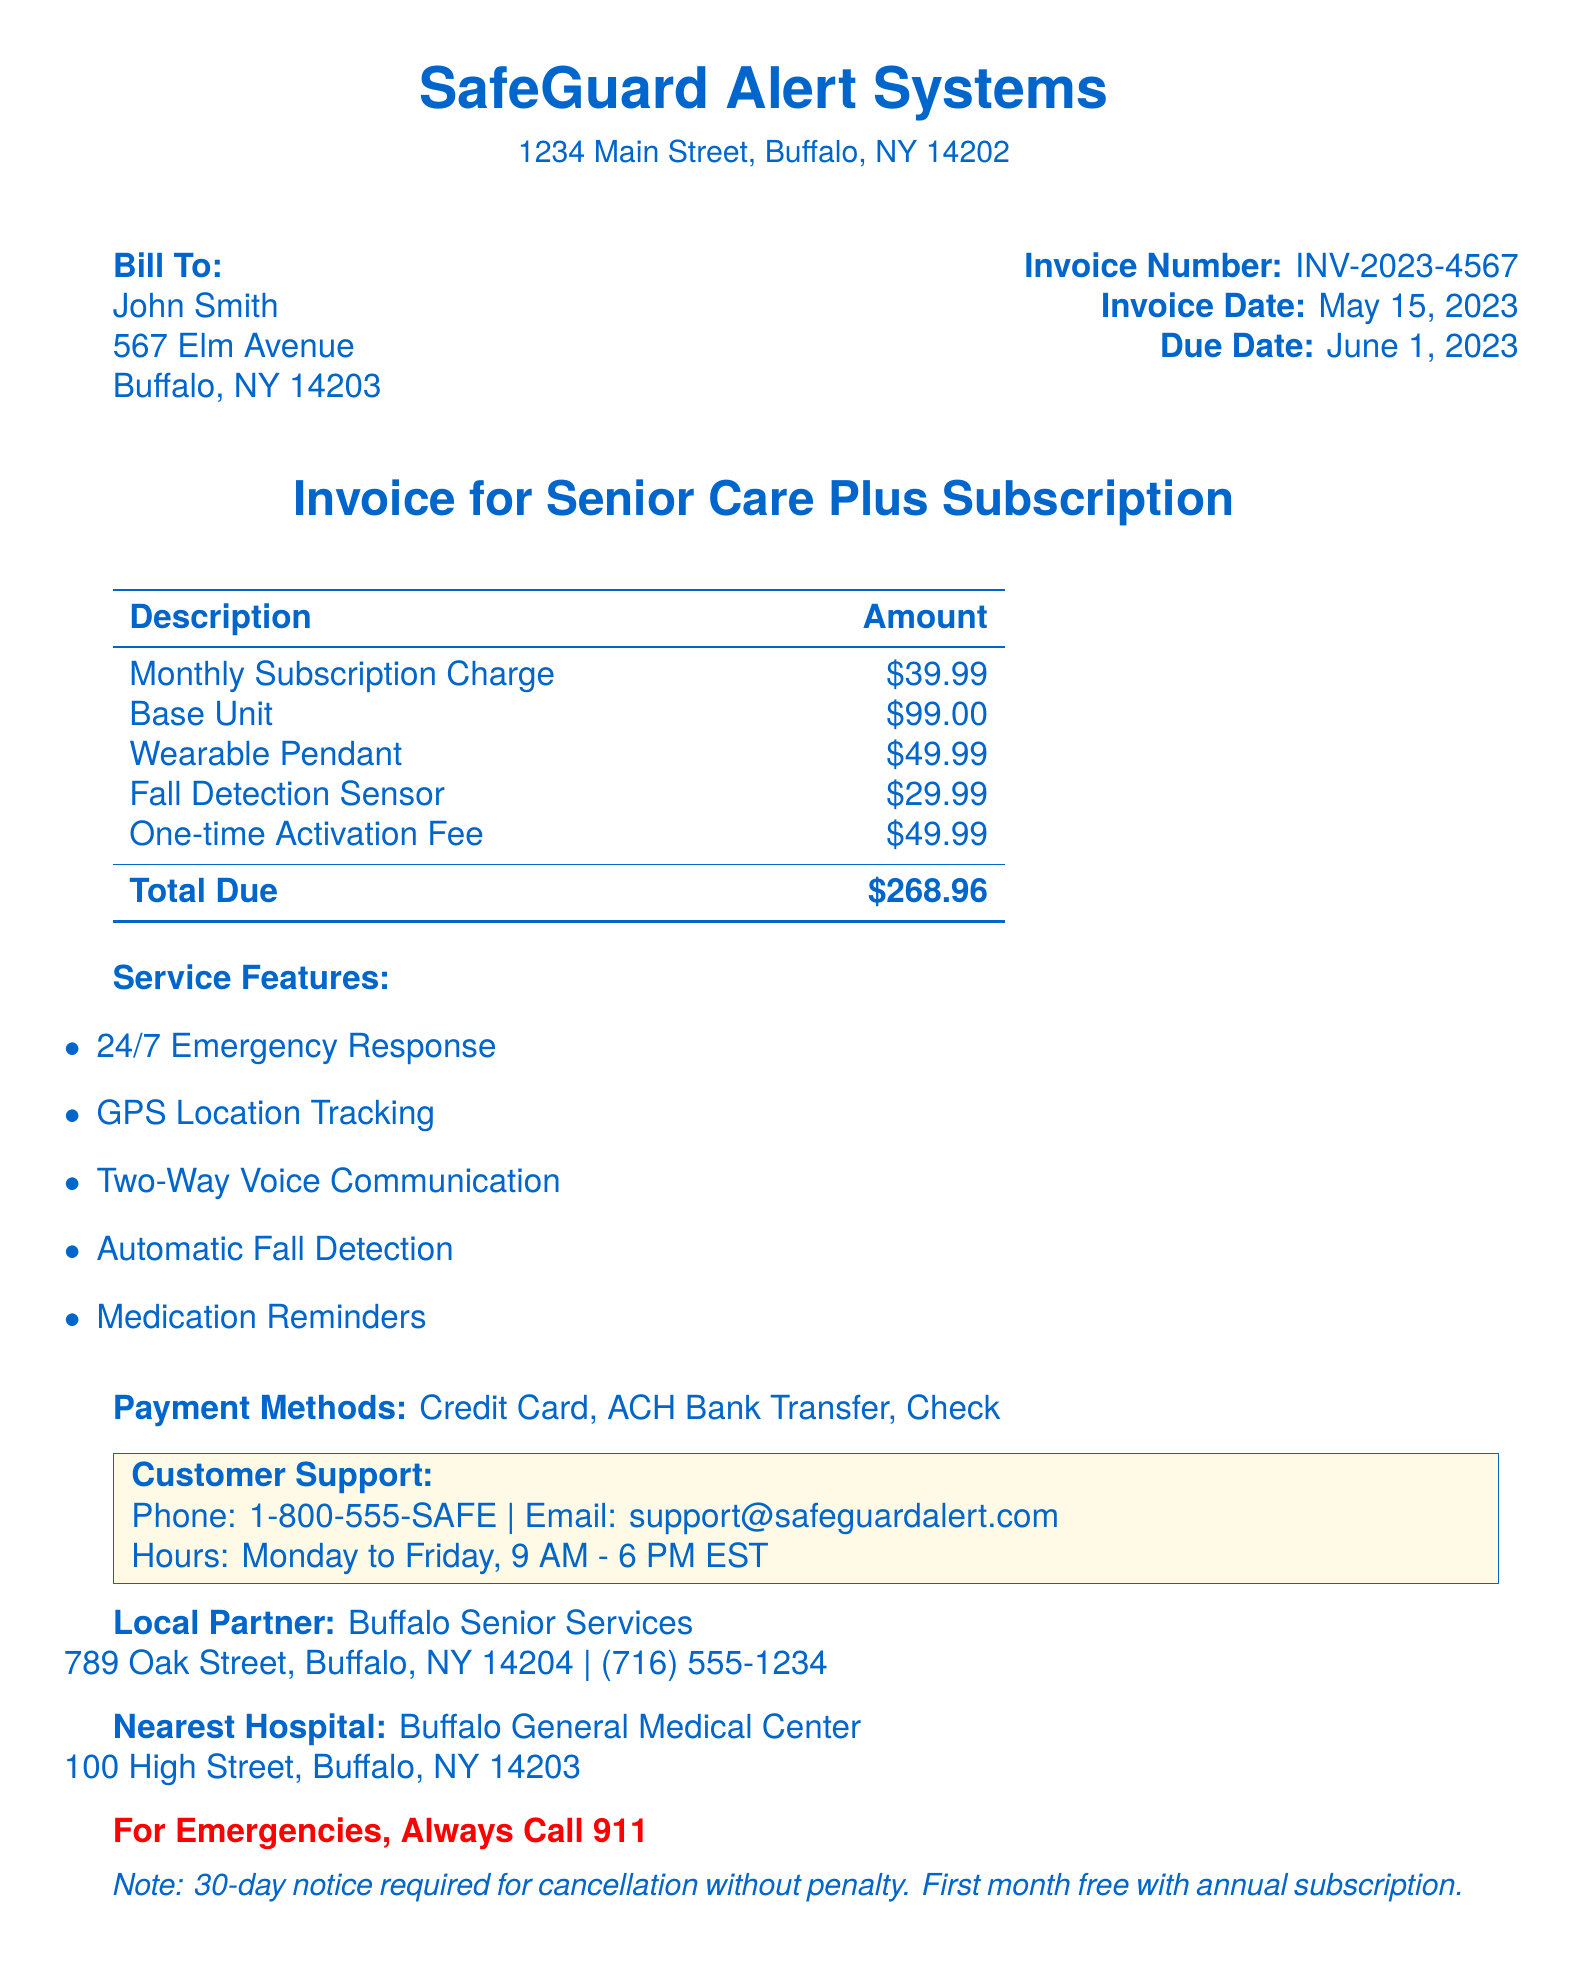what is the company name? The company name is indicated at the top of the document.
Answer: SafeGuard Alert Systems what is the invoice number? The invoice number is specified in the document alongside the invoice date and due date.
Answer: INV-2023-4567 what is the monthly subscription charge? The monthly subscription charge is listed in the invoice details.
Answer: $39.99 what is the total amount due? The total due is computed based on the individual charges listed in the document.
Answer: $268.96 when is the payment due date? The payment due date is explicitly provided in the document section containing billing details.
Answer: June 1, 2023 what is the one-time activation fee? This fee is detailed in the invoice along with other charges.
Answer: $49.99 what are the payment methods available? This information is presented under payment options in the document.
Answer: Credit Card, ACH Bank Transfer, Check what features does the subscription include? The features are listed in the service features section of the document.
Answer: 24/7 Emergency Response, GPS Location Tracking, Two-Way Voice Communication, Automatic Fall Detection, Medication Reminders what is the cancellation policy? The cancellation policy is specified towards the end of the document.
Answer: 30-day notice required for cancellation without penalty 